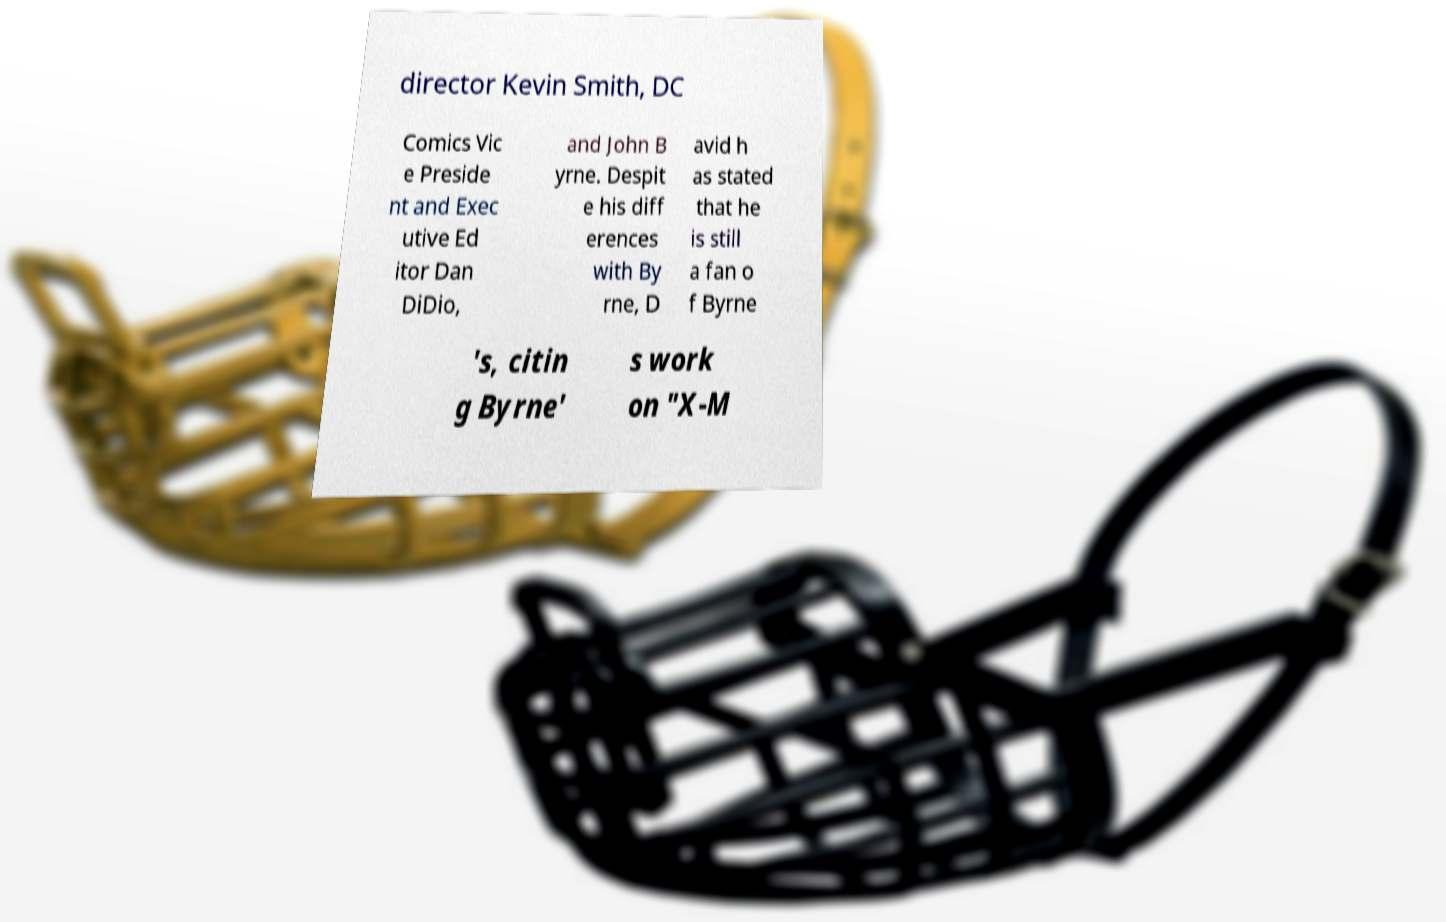I need the written content from this picture converted into text. Can you do that? director Kevin Smith, DC Comics Vic e Preside nt and Exec utive Ed itor Dan DiDio, and John B yrne. Despit e his diff erences with By rne, D avid h as stated that he is still a fan o f Byrne 's, citin g Byrne' s work on "X-M 